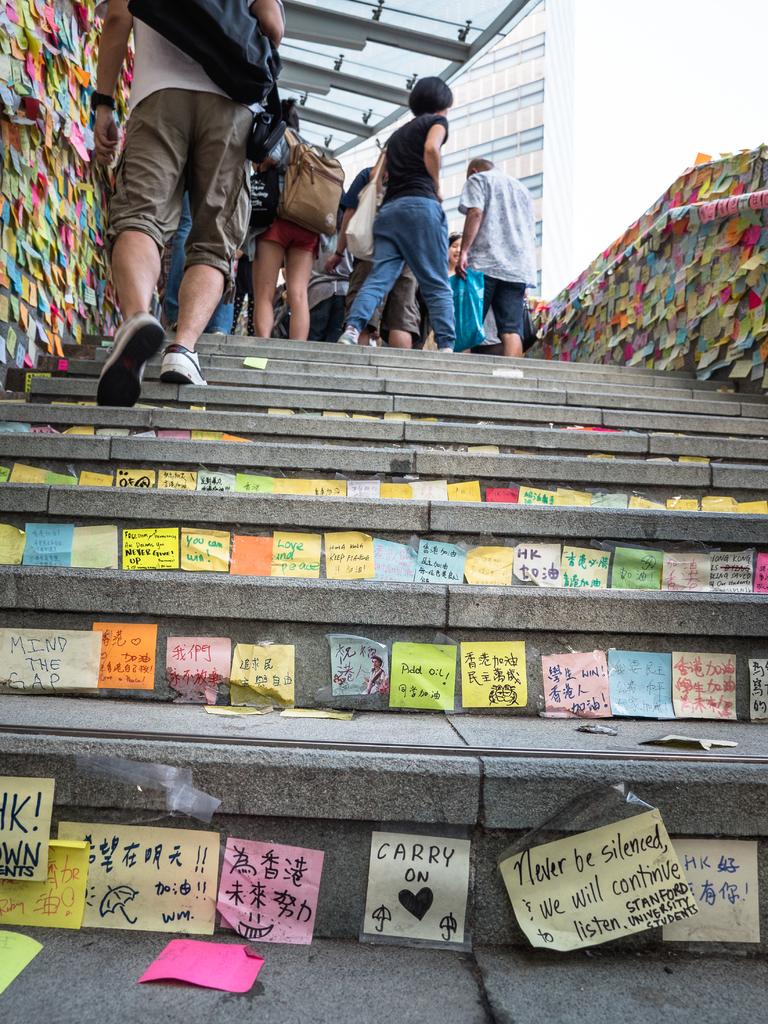What does the sticky note with the heart on it say?
Your answer should be compact. Carry on. 